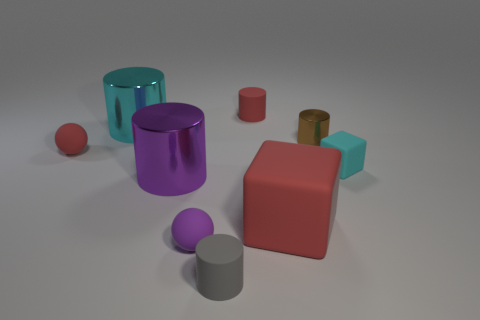Add 1 tiny yellow cylinders. How many objects exist? 10 Subtract all red matte cylinders. How many cylinders are left? 4 Subtract all red balls. How many balls are left? 1 Subtract all cylinders. How many objects are left? 4 Subtract all yellow spheres. Subtract all brown blocks. How many spheres are left? 2 Subtract all yellow blocks. How many gray spheres are left? 0 Subtract all cyan rubber balls. Subtract all tiny brown cylinders. How many objects are left? 8 Add 9 tiny cyan matte things. How many tiny cyan matte things are left? 10 Add 5 cyan rubber things. How many cyan rubber things exist? 6 Subtract 0 green spheres. How many objects are left? 9 